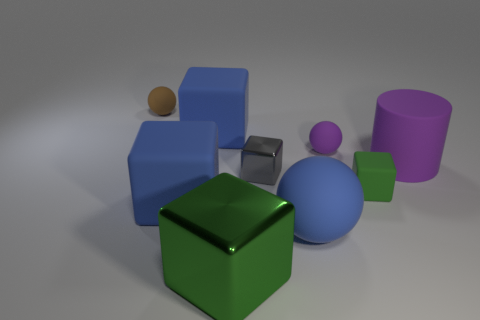Subtract all gray blocks. How many blocks are left? 4 Subtract all brown blocks. Subtract all blue cylinders. How many blocks are left? 5 Add 1 green rubber blocks. How many objects exist? 10 Subtract all cubes. How many objects are left? 4 Subtract 1 purple cylinders. How many objects are left? 8 Subtract all large purple metallic objects. Subtract all green rubber cubes. How many objects are left? 8 Add 6 big green cubes. How many big green cubes are left? 7 Add 2 big yellow metal cubes. How many big yellow metal cubes exist? 2 